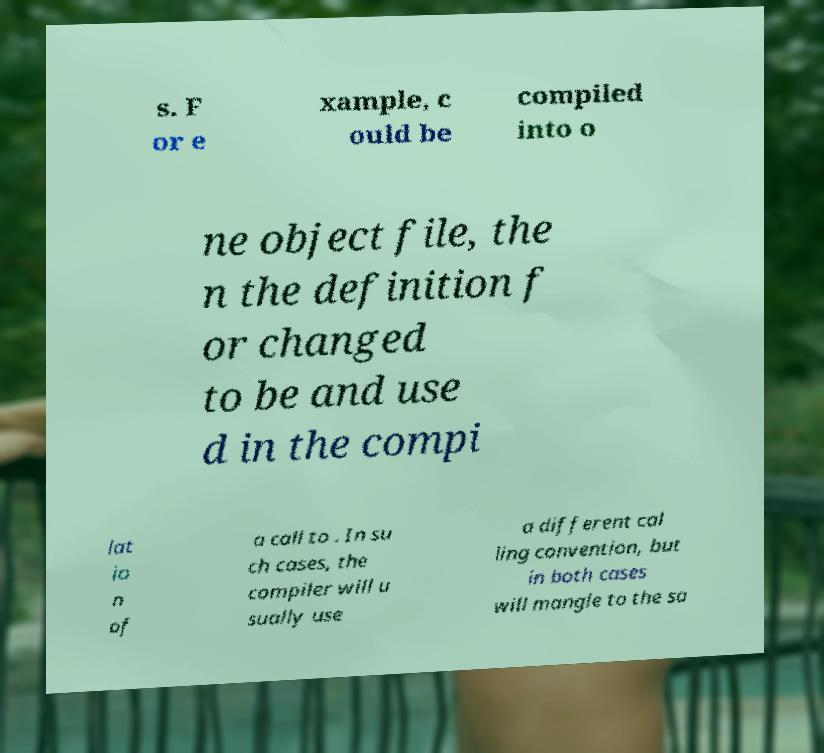Could you assist in decoding the text presented in this image and type it out clearly? s. F or e xample, c ould be compiled into o ne object file, the n the definition f or changed to be and use d in the compi lat io n of a call to . In su ch cases, the compiler will u sually use a different cal ling convention, but in both cases will mangle to the sa 